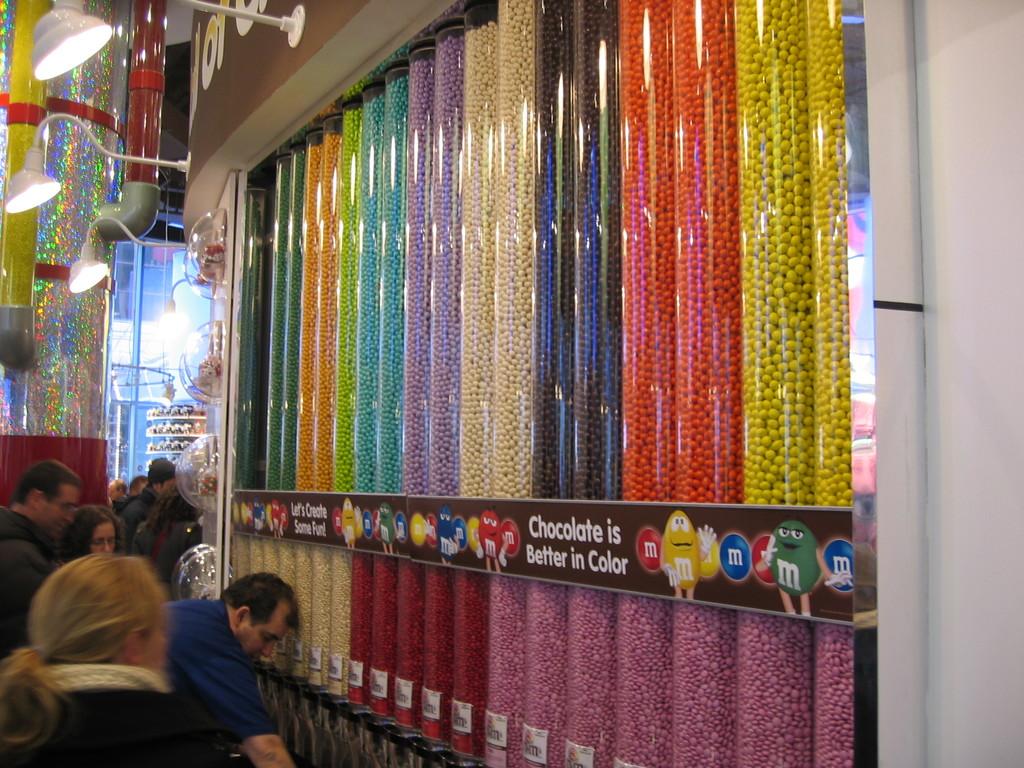What is better in color?
Your answer should be very brief. Chocolate. What letter is on the candy?
Ensure brevity in your answer.  M. 